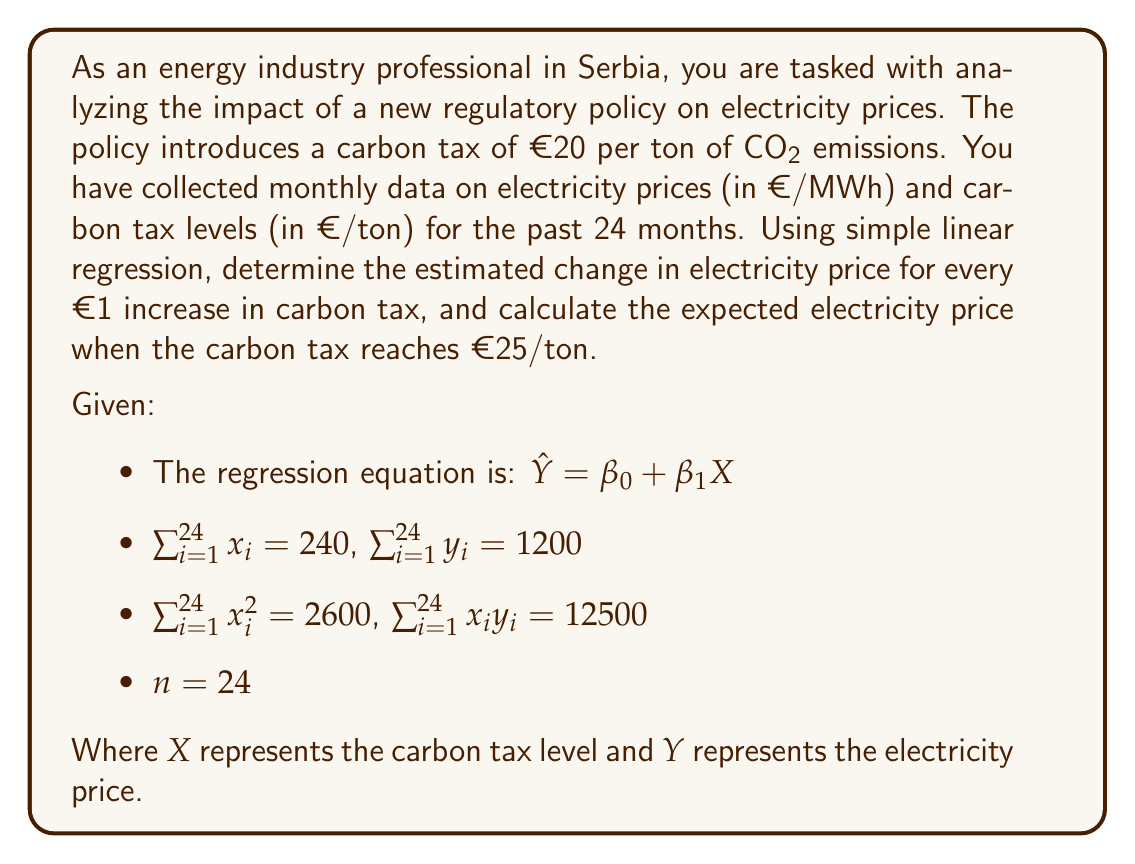What is the answer to this math problem? To solve this problem, we'll use simple linear regression to estimate the relationship between carbon tax levels and electricity prices.

Step 1: Calculate the slope ($\beta_1$) of the regression line.

The formula for $\beta_1$ is:

$$\beta_1 = \frac{n\sum x_iy_i - \sum x_i \sum y_i}{n\sum x_i^2 - (\sum x_i)^2}$$

Substituting the given values:

$$\beta_1 = \frac{24(12500) - (240)(1200)}{24(2600) - (240)^2}$$

$$\beta_1 = \frac{300000 - 288000}{62400 - 57600} = \frac{12000}{4800} = 2.5$$

Step 2: Calculate the y-intercept ($\beta_0$) of the regression line.

The formula for $\beta_0$ is:

$$\beta_0 = \frac{\sum y_i - \beta_1 \sum x_i}{n}$$

Substituting the values:

$$\beta_0 = \frac{1200 - 2.5(240)}{24} = \frac{1200 - 600}{24} = 25$$

Step 3: Write the regression equation.

$$\hat{Y} = 25 + 2.5X$$

This equation suggests that for every €1 increase in carbon tax, the electricity price is estimated to increase by €2.5/MWh.

Step 4: Calculate the expected electricity price when the carbon tax is €25/ton.

Substitute $X = 25$ into the regression equation:

$$\hat{Y} = 25 + 2.5(25) = 25 + 62.5 = 87.5$$

Therefore, when the carbon tax reaches €25/ton, the expected electricity price is €87.5/MWh.
Answer: The estimated change in electricity price for every €1 increase in carbon tax is €2.5/MWh. The expected electricity price when the carbon tax reaches €25/ton is €87.5/MWh. 